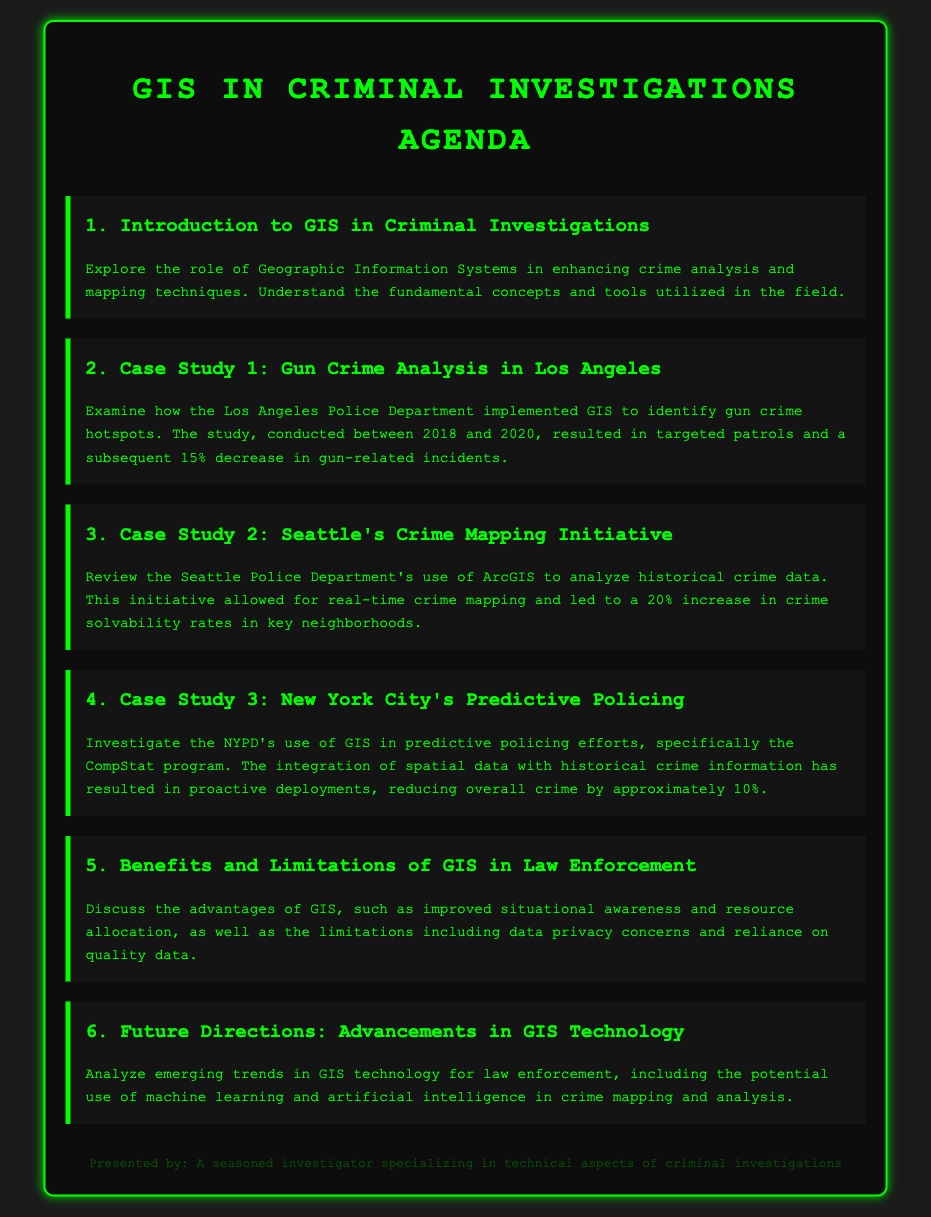What is the title of the document? The title of the document, as specified in the `<title>` tag, is "GIS in Criminal Investigations Agenda."
Answer: GIS in Criminal Investigations Agenda How many case studies are highlighted in the agenda? The agenda lists three case studies, specifically numbered in the sections.
Answer: 3 What was the percentage decrease in gun-related incidents in Los Angeles? The second case study mentions a 15% decrease in gun-related incidents due to GIS implementation.
Answer: 15% What tool did the Seattle Police Department use for crime mapping? The document states that the Seattle Police Department used ArcGIS for analyzing historical crime data.
Answer: ArcGIS What year range does the Los Angeles case study cover? The document specifies that the case study on gun crime analysis in Los Angeles was conducted between 2018 and 2020.
Answer: 2018 to 2020 What is one of the limitations of GIS mentioned in the agenda? The agenda outlines data privacy concerns as a limitation of GIS in law enforcement.
Answer: Data privacy concerns What was the percentage increase in crime solvability rates in Seattle? The Seattle case study indicated a 20% increase in crime solvability rates in key neighborhoods.
Answer: 20% What is a future advancement mentioned for GIS technology? The agenda discusses the potential use of machine learning and artificial intelligence as emerging trends in GIS technology for law enforcement.
Answer: Machine learning and artificial intelligence 